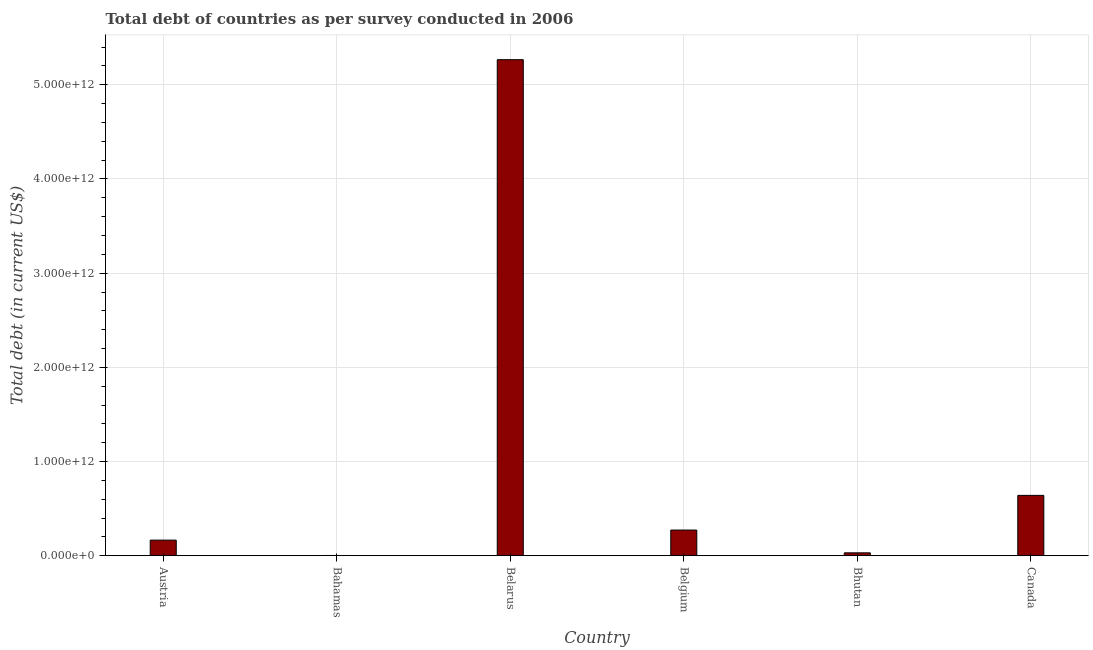What is the title of the graph?
Your response must be concise. Total debt of countries as per survey conducted in 2006. What is the label or title of the X-axis?
Provide a succinct answer. Country. What is the label or title of the Y-axis?
Offer a terse response. Total debt (in current US$). What is the total debt in Canada?
Offer a terse response. 6.41e+11. Across all countries, what is the maximum total debt?
Ensure brevity in your answer.  5.27e+12. Across all countries, what is the minimum total debt?
Your response must be concise. 2.39e+09. In which country was the total debt maximum?
Provide a succinct answer. Belarus. In which country was the total debt minimum?
Keep it short and to the point. Bahamas. What is the sum of the total debt?
Your answer should be compact. 6.38e+12. What is the difference between the total debt in Austria and Bahamas?
Your answer should be very brief. 1.63e+11. What is the average total debt per country?
Keep it short and to the point. 1.06e+12. What is the median total debt?
Provide a short and direct response. 2.19e+11. In how many countries, is the total debt greater than 2800000000000 US$?
Offer a very short reply. 1. What is the ratio of the total debt in Bahamas to that in Belgium?
Keep it short and to the point. 0.01. Is the total debt in Bahamas less than that in Belarus?
Your response must be concise. Yes. What is the difference between the highest and the second highest total debt?
Your answer should be compact. 4.63e+12. What is the difference between the highest and the lowest total debt?
Offer a very short reply. 5.26e+12. In how many countries, is the total debt greater than the average total debt taken over all countries?
Your answer should be compact. 1. How many bars are there?
Your response must be concise. 6. Are all the bars in the graph horizontal?
Ensure brevity in your answer.  No. What is the difference between two consecutive major ticks on the Y-axis?
Give a very brief answer. 1.00e+12. What is the Total debt (in current US$) in Austria?
Your response must be concise. 1.65e+11. What is the Total debt (in current US$) in Bahamas?
Offer a very short reply. 2.39e+09. What is the Total debt (in current US$) in Belarus?
Your answer should be very brief. 5.27e+12. What is the Total debt (in current US$) of Belgium?
Ensure brevity in your answer.  2.72e+11. What is the Total debt (in current US$) of Bhutan?
Ensure brevity in your answer.  3.05e+1. What is the Total debt (in current US$) in Canada?
Your answer should be compact. 6.41e+11. What is the difference between the Total debt (in current US$) in Austria and Bahamas?
Make the answer very short. 1.63e+11. What is the difference between the Total debt (in current US$) in Austria and Belarus?
Ensure brevity in your answer.  -5.10e+12. What is the difference between the Total debt (in current US$) in Austria and Belgium?
Offer a very short reply. -1.07e+11. What is the difference between the Total debt (in current US$) in Austria and Bhutan?
Offer a very short reply. 1.35e+11. What is the difference between the Total debt (in current US$) in Austria and Canada?
Your answer should be compact. -4.75e+11. What is the difference between the Total debt (in current US$) in Bahamas and Belarus?
Ensure brevity in your answer.  -5.26e+12. What is the difference between the Total debt (in current US$) in Bahamas and Belgium?
Keep it short and to the point. -2.70e+11. What is the difference between the Total debt (in current US$) in Bahamas and Bhutan?
Your response must be concise. -2.81e+1. What is the difference between the Total debt (in current US$) in Bahamas and Canada?
Provide a short and direct response. -6.38e+11. What is the difference between the Total debt (in current US$) in Belarus and Belgium?
Ensure brevity in your answer.  4.99e+12. What is the difference between the Total debt (in current US$) in Belarus and Bhutan?
Ensure brevity in your answer.  5.24e+12. What is the difference between the Total debt (in current US$) in Belarus and Canada?
Make the answer very short. 4.63e+12. What is the difference between the Total debt (in current US$) in Belgium and Bhutan?
Your answer should be very brief. 2.42e+11. What is the difference between the Total debt (in current US$) in Belgium and Canada?
Provide a short and direct response. -3.68e+11. What is the difference between the Total debt (in current US$) in Bhutan and Canada?
Provide a short and direct response. -6.10e+11. What is the ratio of the Total debt (in current US$) in Austria to that in Bahamas?
Your response must be concise. 69.28. What is the ratio of the Total debt (in current US$) in Austria to that in Belarus?
Your answer should be very brief. 0.03. What is the ratio of the Total debt (in current US$) in Austria to that in Belgium?
Offer a very short reply. 0.61. What is the ratio of the Total debt (in current US$) in Austria to that in Bhutan?
Your answer should be compact. 5.43. What is the ratio of the Total debt (in current US$) in Austria to that in Canada?
Your answer should be very brief. 0.26. What is the ratio of the Total debt (in current US$) in Bahamas to that in Belarus?
Offer a terse response. 0. What is the ratio of the Total debt (in current US$) in Bahamas to that in Belgium?
Ensure brevity in your answer.  0.01. What is the ratio of the Total debt (in current US$) in Bahamas to that in Bhutan?
Offer a terse response. 0.08. What is the ratio of the Total debt (in current US$) in Bahamas to that in Canada?
Make the answer very short. 0. What is the ratio of the Total debt (in current US$) in Belarus to that in Belgium?
Ensure brevity in your answer.  19.33. What is the ratio of the Total debt (in current US$) in Belarus to that in Bhutan?
Make the answer very short. 172.92. What is the ratio of the Total debt (in current US$) in Belarus to that in Canada?
Your answer should be compact. 8.22. What is the ratio of the Total debt (in current US$) in Belgium to that in Bhutan?
Your answer should be very brief. 8.94. What is the ratio of the Total debt (in current US$) in Belgium to that in Canada?
Your response must be concise. 0.42. What is the ratio of the Total debt (in current US$) in Bhutan to that in Canada?
Your response must be concise. 0.05. 